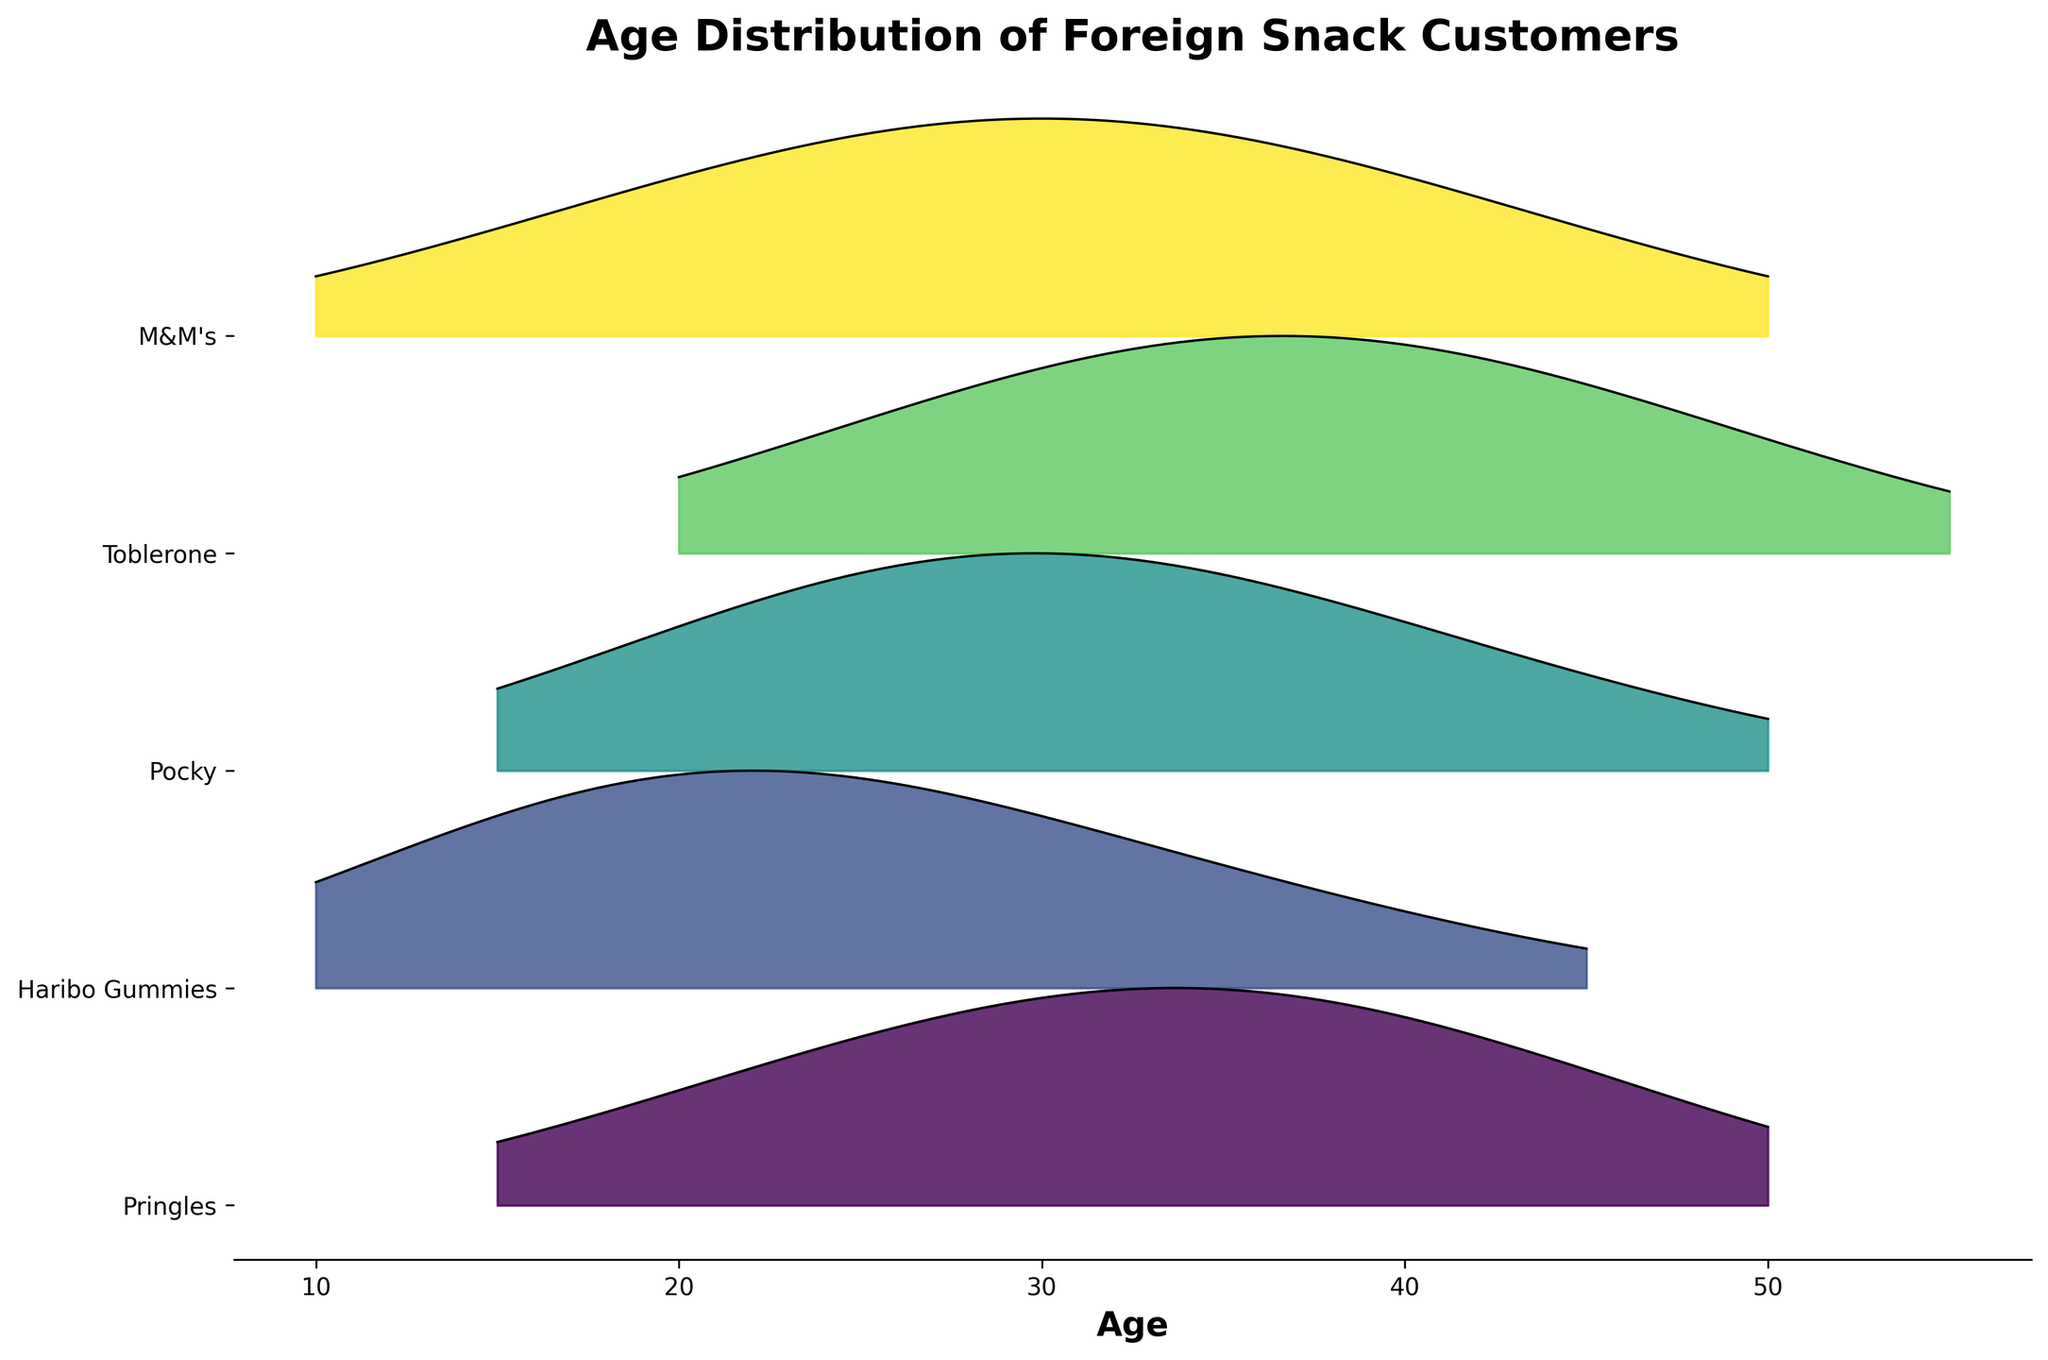Which snack shows the highest peak density in the age range between 30 to 40? By observing the peaks in the Ridgeline plot, we notice the highest peak density here belongs to Toblerone, which peaks at an age of around 35 years.
Answer: Toblerone Which snack type has the broadest age distribution? The snack type with the broadest age distribution is identified by observing which density curve spans the widest age range. Toblerone's distribution runs from 20 to 55 years, which is the broadest.
Answer: Toblerone What is the age range where Haribo Gummies has the highest density? By examining the density peaks for Haribo Gummies, we observe the highest peak around the age of 20.
Answer: 20 What is the peak density for Pringles, and at what age does it occur? By looking at the peak point of the density curve for Pringles, we find the highest density occurs at 35 years.
Answer: 35 Which snack has the most pronounced peak density in older age groups (45 and above)? The snack with the most pronounced peak density above age 45 can be identified by observing which snack's density curve peaks most significantly in that age range. Toblerone peaks the most around 45 to 50.
Answer: Toblerone How does the density peak of Pocky at age 30 compare to that of M&M's at the same age? Comparing the heights of the peaks at age 30, Pocky's peak is slightly higher than that of M&M's.
Answer: Pocky is higher Are the age ranges for Pringles and Haribo Gummies overlapping, and to what extent? By comparing the spans of the density curves for Pringles and Haribo Gummies, we see that their age ranges overlap between 15 and 45 years.
Answer: 15 to 45 years What is the general trend of the density curves for the snacks from younger to older age groups? Observing all the density curves from left to right (younger to older age), each snack type typically starts with lower density in younger age groups, reaches a peak at varying middle ages, and then decreases in density towards older age groups.
Answer: Peak at mid-ages, lower at younger and older ages Which snack types have a density peak at age 25, and how do these peaks compare? By noting the peaks at age 25 for all snack types, Haribo Gummies, Pocky, and M&M's exhibit density peaks. M&M's and Pocky's peaks at age 25 are similar and higher than that of Haribo Gummies.
Answer: M&M's and Pocky higher than Haribo Gummies Between which ages does the density for M&M's remain relatively high? Observing the M&M's density curve, it remains relatively high in the age range from 25 to 35.
Answer: 25 to 35 